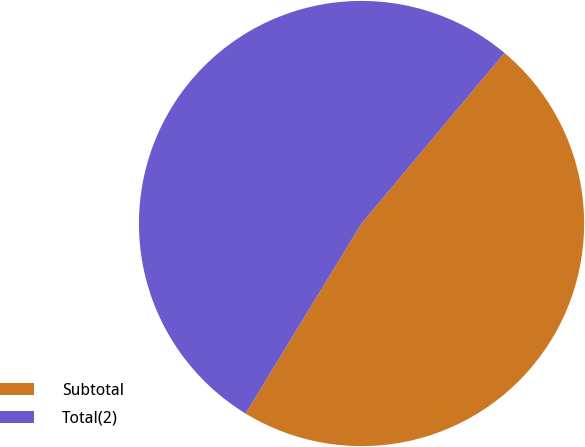Convert chart. <chart><loc_0><loc_0><loc_500><loc_500><pie_chart><fcel>Subtotal<fcel>Total(2)<nl><fcel>47.62%<fcel>52.38%<nl></chart> 